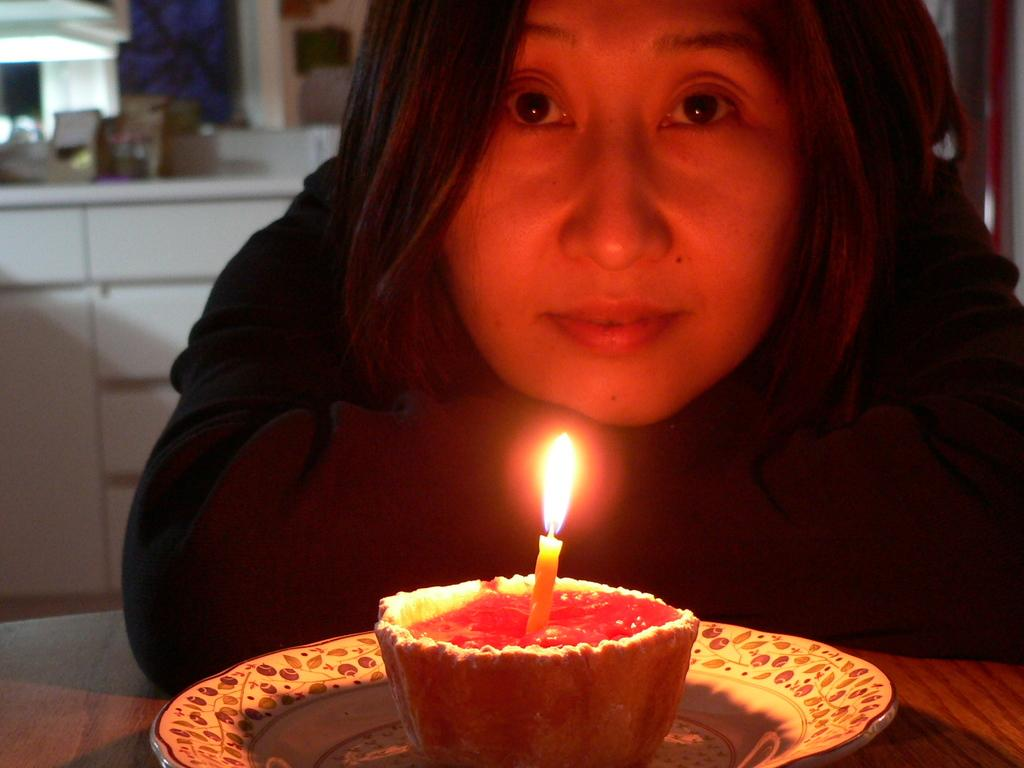Who is present in the image? There is a woman in the image. What is the woman wearing? The woman is wearing a black dress. What else can be seen in the image besides the woman? There is food visible in the image, and there is a candle on the food. What company does the woman work for in the image? There is no information about the woman's company or occupation in the image. Is the woman crying in the image? There is no indication that the woman is crying in the image. 